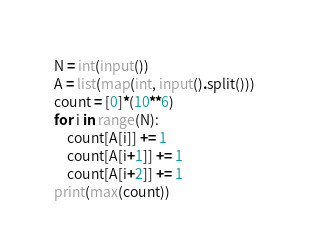<code> <loc_0><loc_0><loc_500><loc_500><_Python_>N = int(input())
A = list(map(int, input().split()))
count = [0]*(10**6)
for i in range(N):
    count[A[i]] += 1
    count[A[i+1]] += 1
    count[A[i+2]] += 1
print(max(count))
</code> 